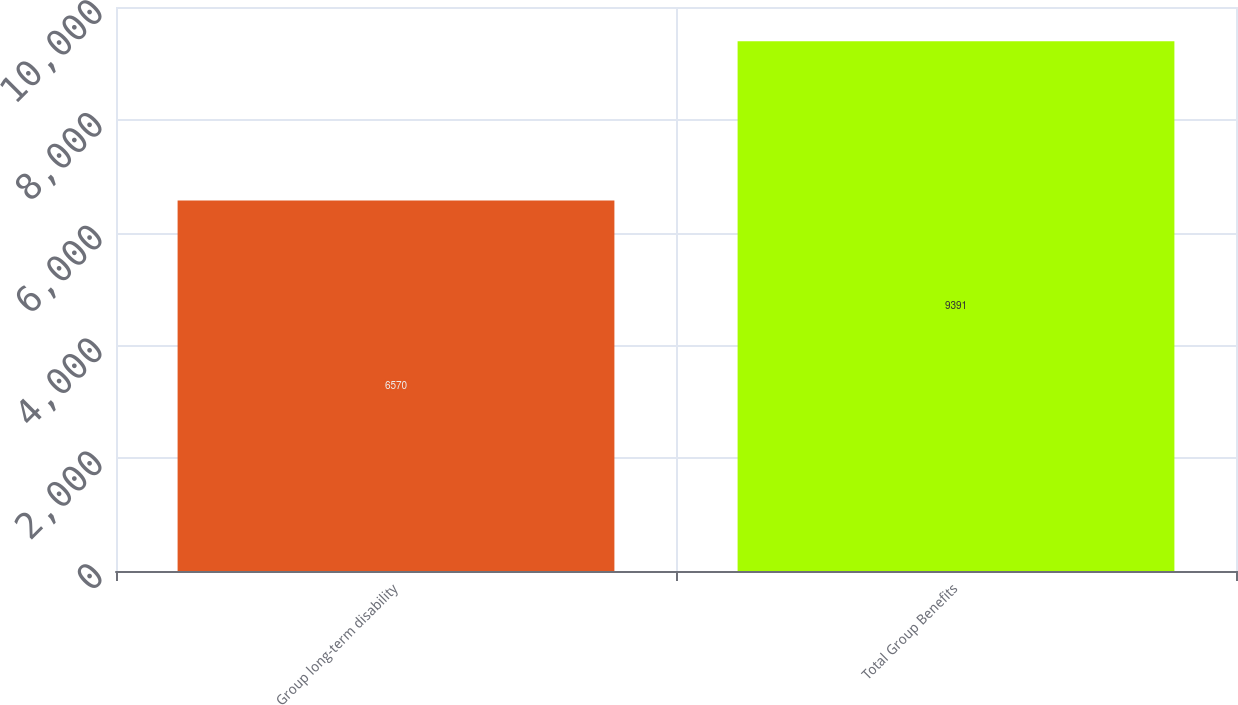Convert chart to OTSL. <chart><loc_0><loc_0><loc_500><loc_500><bar_chart><fcel>Group long-term disability<fcel>Total Group Benefits<nl><fcel>6570<fcel>9391<nl></chart> 